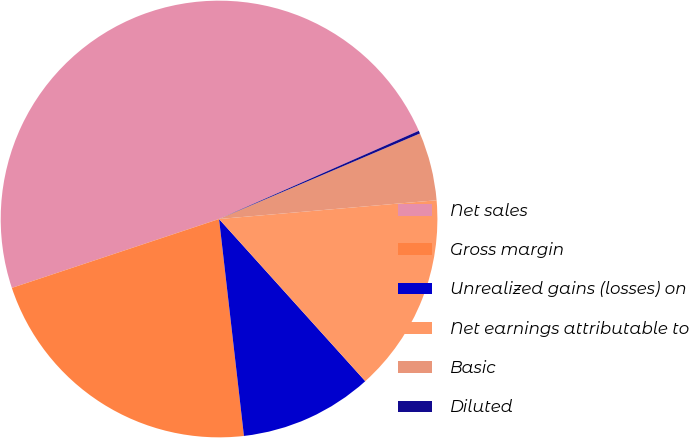<chart> <loc_0><loc_0><loc_500><loc_500><pie_chart><fcel>Net sales<fcel>Gross margin<fcel>Unrealized gains (losses) on<fcel>Net earnings attributable to<fcel>Basic<fcel>Diluted<nl><fcel>48.49%<fcel>21.71%<fcel>9.86%<fcel>14.69%<fcel>5.04%<fcel>0.21%<nl></chart> 